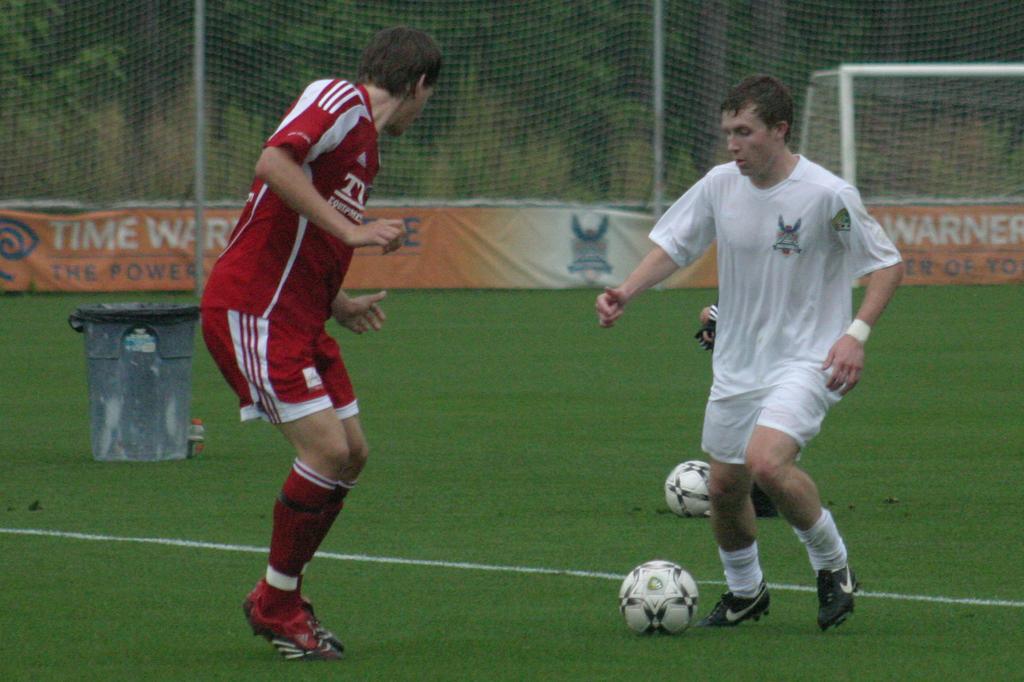Who is the sponsor on the banner?
Offer a very short reply. Time warner. 